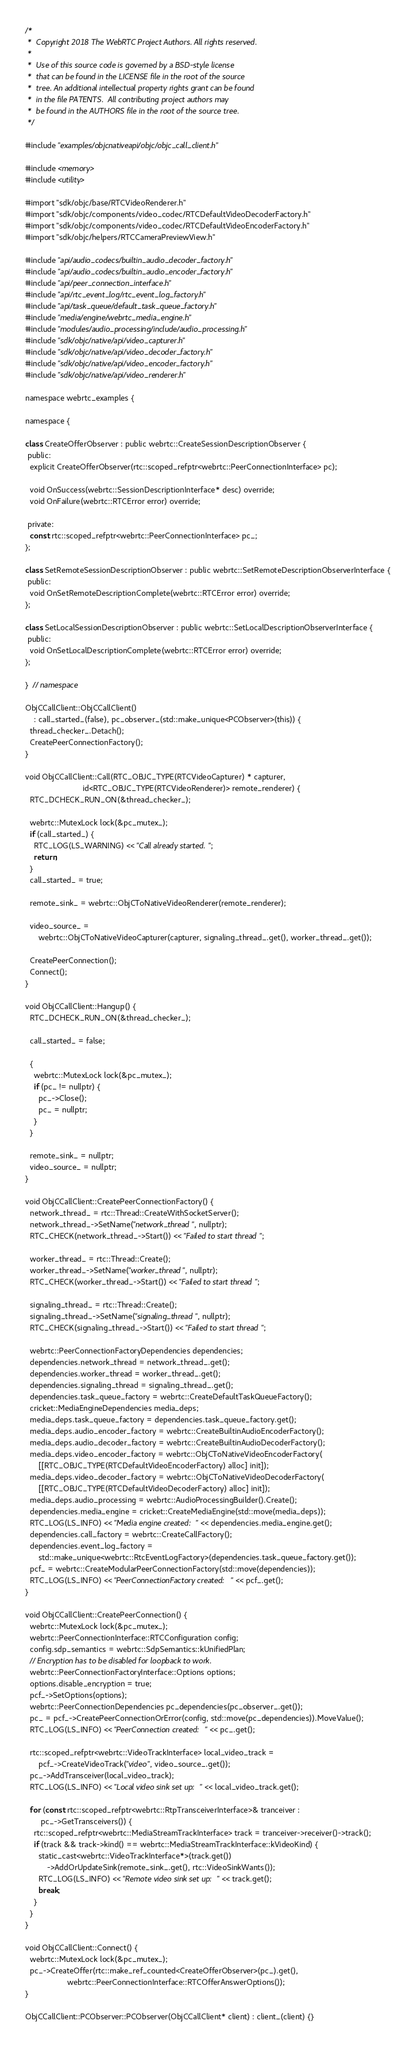<code> <loc_0><loc_0><loc_500><loc_500><_ObjectiveC_>/*
 *  Copyright 2018 The WebRTC Project Authors. All rights reserved.
 *
 *  Use of this source code is governed by a BSD-style license
 *  that can be found in the LICENSE file in the root of the source
 *  tree. An additional intellectual property rights grant can be found
 *  in the file PATENTS.  All contributing project authors may
 *  be found in the AUTHORS file in the root of the source tree.
 */

#include "examples/objcnativeapi/objc/objc_call_client.h"

#include <memory>
#include <utility>

#import "sdk/objc/base/RTCVideoRenderer.h"
#import "sdk/objc/components/video_codec/RTCDefaultVideoDecoderFactory.h"
#import "sdk/objc/components/video_codec/RTCDefaultVideoEncoderFactory.h"
#import "sdk/objc/helpers/RTCCameraPreviewView.h"

#include "api/audio_codecs/builtin_audio_decoder_factory.h"
#include "api/audio_codecs/builtin_audio_encoder_factory.h"
#include "api/peer_connection_interface.h"
#include "api/rtc_event_log/rtc_event_log_factory.h"
#include "api/task_queue/default_task_queue_factory.h"
#include "media/engine/webrtc_media_engine.h"
#include "modules/audio_processing/include/audio_processing.h"
#include "sdk/objc/native/api/video_capturer.h"
#include "sdk/objc/native/api/video_decoder_factory.h"
#include "sdk/objc/native/api/video_encoder_factory.h"
#include "sdk/objc/native/api/video_renderer.h"

namespace webrtc_examples {

namespace {

class CreateOfferObserver : public webrtc::CreateSessionDescriptionObserver {
 public:
  explicit CreateOfferObserver(rtc::scoped_refptr<webrtc::PeerConnectionInterface> pc);

  void OnSuccess(webrtc::SessionDescriptionInterface* desc) override;
  void OnFailure(webrtc::RTCError error) override;

 private:
  const rtc::scoped_refptr<webrtc::PeerConnectionInterface> pc_;
};

class SetRemoteSessionDescriptionObserver : public webrtc::SetRemoteDescriptionObserverInterface {
 public:
  void OnSetRemoteDescriptionComplete(webrtc::RTCError error) override;
};

class SetLocalSessionDescriptionObserver : public webrtc::SetLocalDescriptionObserverInterface {
 public:
  void OnSetLocalDescriptionComplete(webrtc::RTCError error) override;
};

}  // namespace

ObjCCallClient::ObjCCallClient()
    : call_started_(false), pc_observer_(std::make_unique<PCObserver>(this)) {
  thread_checker_.Detach();
  CreatePeerConnectionFactory();
}

void ObjCCallClient::Call(RTC_OBJC_TYPE(RTCVideoCapturer) * capturer,
                          id<RTC_OBJC_TYPE(RTCVideoRenderer)> remote_renderer) {
  RTC_DCHECK_RUN_ON(&thread_checker_);

  webrtc::MutexLock lock(&pc_mutex_);
  if (call_started_) {
    RTC_LOG(LS_WARNING) << "Call already started.";
    return;
  }
  call_started_ = true;

  remote_sink_ = webrtc::ObjCToNativeVideoRenderer(remote_renderer);

  video_source_ =
      webrtc::ObjCToNativeVideoCapturer(capturer, signaling_thread_.get(), worker_thread_.get());

  CreatePeerConnection();
  Connect();
}

void ObjCCallClient::Hangup() {
  RTC_DCHECK_RUN_ON(&thread_checker_);

  call_started_ = false;

  {
    webrtc::MutexLock lock(&pc_mutex_);
    if (pc_ != nullptr) {
      pc_->Close();
      pc_ = nullptr;
    }
  }

  remote_sink_ = nullptr;
  video_source_ = nullptr;
}

void ObjCCallClient::CreatePeerConnectionFactory() {
  network_thread_ = rtc::Thread::CreateWithSocketServer();
  network_thread_->SetName("network_thread", nullptr);
  RTC_CHECK(network_thread_->Start()) << "Failed to start thread";

  worker_thread_ = rtc::Thread::Create();
  worker_thread_->SetName("worker_thread", nullptr);
  RTC_CHECK(worker_thread_->Start()) << "Failed to start thread";

  signaling_thread_ = rtc::Thread::Create();
  signaling_thread_->SetName("signaling_thread", nullptr);
  RTC_CHECK(signaling_thread_->Start()) << "Failed to start thread";

  webrtc::PeerConnectionFactoryDependencies dependencies;
  dependencies.network_thread = network_thread_.get();
  dependencies.worker_thread = worker_thread_.get();
  dependencies.signaling_thread = signaling_thread_.get();
  dependencies.task_queue_factory = webrtc::CreateDefaultTaskQueueFactory();
  cricket::MediaEngineDependencies media_deps;
  media_deps.task_queue_factory = dependencies.task_queue_factory.get();
  media_deps.audio_encoder_factory = webrtc::CreateBuiltinAudioEncoderFactory();
  media_deps.audio_decoder_factory = webrtc::CreateBuiltinAudioDecoderFactory();
  media_deps.video_encoder_factory = webrtc::ObjCToNativeVideoEncoderFactory(
      [[RTC_OBJC_TYPE(RTCDefaultVideoEncoderFactory) alloc] init]);
  media_deps.video_decoder_factory = webrtc::ObjCToNativeVideoDecoderFactory(
      [[RTC_OBJC_TYPE(RTCDefaultVideoDecoderFactory) alloc] init]);
  media_deps.audio_processing = webrtc::AudioProcessingBuilder().Create();
  dependencies.media_engine = cricket::CreateMediaEngine(std::move(media_deps));
  RTC_LOG(LS_INFO) << "Media engine created: " << dependencies.media_engine.get();
  dependencies.call_factory = webrtc::CreateCallFactory();
  dependencies.event_log_factory =
      std::make_unique<webrtc::RtcEventLogFactory>(dependencies.task_queue_factory.get());
  pcf_ = webrtc::CreateModularPeerConnectionFactory(std::move(dependencies));
  RTC_LOG(LS_INFO) << "PeerConnectionFactory created: " << pcf_.get();
}

void ObjCCallClient::CreatePeerConnection() {
  webrtc::MutexLock lock(&pc_mutex_);
  webrtc::PeerConnectionInterface::RTCConfiguration config;
  config.sdp_semantics = webrtc::SdpSemantics::kUnifiedPlan;
  // Encryption has to be disabled for loopback to work.
  webrtc::PeerConnectionFactoryInterface::Options options;
  options.disable_encryption = true;
  pcf_->SetOptions(options);
  webrtc::PeerConnectionDependencies pc_dependencies(pc_observer_.get());
  pc_ = pcf_->CreatePeerConnectionOrError(config, std::move(pc_dependencies)).MoveValue();
  RTC_LOG(LS_INFO) << "PeerConnection created: " << pc_.get();

  rtc::scoped_refptr<webrtc::VideoTrackInterface> local_video_track =
      pcf_->CreateVideoTrack("video", video_source_.get());
  pc_->AddTransceiver(local_video_track);
  RTC_LOG(LS_INFO) << "Local video sink set up: " << local_video_track.get();

  for (const rtc::scoped_refptr<webrtc::RtpTransceiverInterface>& tranceiver :
       pc_->GetTransceivers()) {
    rtc::scoped_refptr<webrtc::MediaStreamTrackInterface> track = tranceiver->receiver()->track();
    if (track && track->kind() == webrtc::MediaStreamTrackInterface::kVideoKind) {
      static_cast<webrtc::VideoTrackInterface*>(track.get())
          ->AddOrUpdateSink(remote_sink_.get(), rtc::VideoSinkWants());
      RTC_LOG(LS_INFO) << "Remote video sink set up: " << track.get();
      break;
    }
  }
}

void ObjCCallClient::Connect() {
  webrtc::MutexLock lock(&pc_mutex_);
  pc_->CreateOffer(rtc::make_ref_counted<CreateOfferObserver>(pc_).get(),
                   webrtc::PeerConnectionInterface::RTCOfferAnswerOptions());
}

ObjCCallClient::PCObserver::PCObserver(ObjCCallClient* client) : client_(client) {}
</code> 